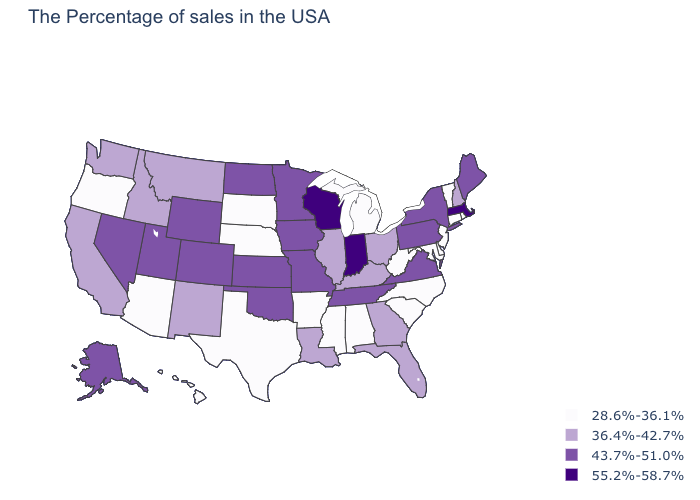How many symbols are there in the legend?
Keep it brief. 4. Name the states that have a value in the range 36.4%-42.7%?
Be succinct. New Hampshire, Ohio, Florida, Georgia, Kentucky, Illinois, Louisiana, New Mexico, Montana, Idaho, California, Washington. Does the first symbol in the legend represent the smallest category?
Answer briefly. Yes. What is the value of Minnesota?
Write a very short answer. 43.7%-51.0%. Does Arizona have the lowest value in the USA?
Concise answer only. Yes. Name the states that have a value in the range 36.4%-42.7%?
Answer briefly. New Hampshire, Ohio, Florida, Georgia, Kentucky, Illinois, Louisiana, New Mexico, Montana, Idaho, California, Washington. What is the value of Minnesota?
Short answer required. 43.7%-51.0%. Name the states that have a value in the range 36.4%-42.7%?
Quick response, please. New Hampshire, Ohio, Florida, Georgia, Kentucky, Illinois, Louisiana, New Mexico, Montana, Idaho, California, Washington. What is the highest value in the USA?
Quick response, please. 55.2%-58.7%. What is the value of Wyoming?
Keep it brief. 43.7%-51.0%. What is the highest value in the South ?
Concise answer only. 43.7%-51.0%. What is the value of Delaware?
Quick response, please. 28.6%-36.1%. What is the lowest value in the USA?
Quick response, please. 28.6%-36.1%. What is the value of Washington?
Concise answer only. 36.4%-42.7%. Does Ohio have the lowest value in the MidWest?
Answer briefly. No. 